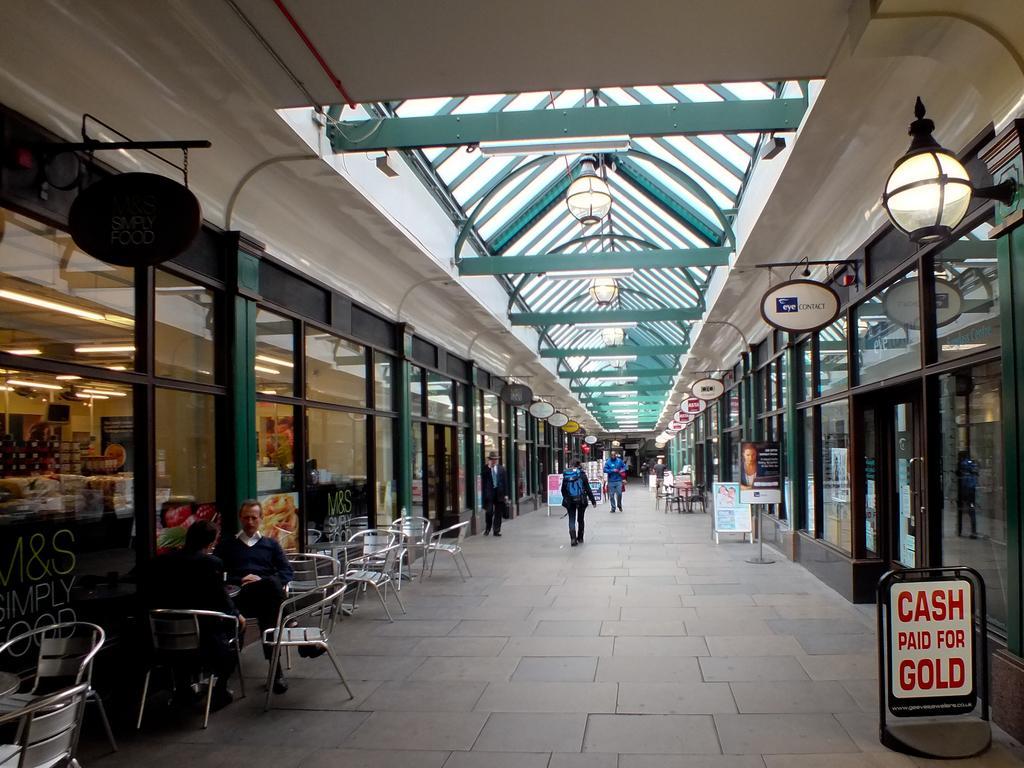Could you give a brief overview of what you see in this image? The picture is taken inside a building. On the right there are hoardings, lamps, chairs, glass windows and doors. On the top it is ceiling, there are lights to the ceiling. In the center on the pavement there are people walking. On the left there are chairs, shops hoardings, glass, windows and doors 